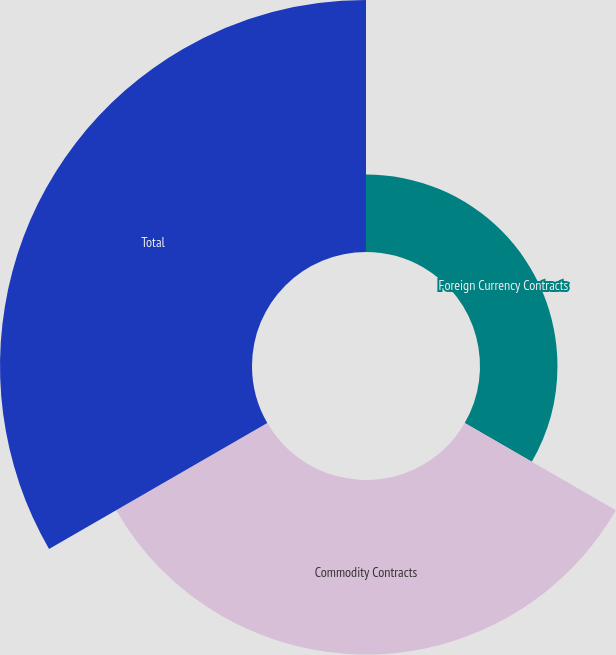<chart> <loc_0><loc_0><loc_500><loc_500><pie_chart><fcel>Foreign Currency Contracts<fcel>Commodity Contracts<fcel>Total<nl><fcel>15.37%<fcel>34.63%<fcel>50.0%<nl></chart> 